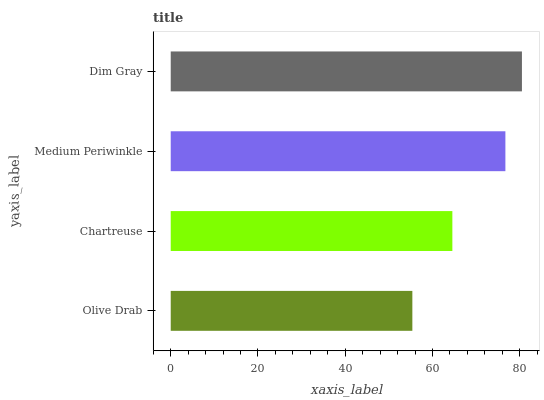Is Olive Drab the minimum?
Answer yes or no. Yes. Is Dim Gray the maximum?
Answer yes or no. Yes. Is Chartreuse the minimum?
Answer yes or no. No. Is Chartreuse the maximum?
Answer yes or no. No. Is Chartreuse greater than Olive Drab?
Answer yes or no. Yes. Is Olive Drab less than Chartreuse?
Answer yes or no. Yes. Is Olive Drab greater than Chartreuse?
Answer yes or no. No. Is Chartreuse less than Olive Drab?
Answer yes or no. No. Is Medium Periwinkle the high median?
Answer yes or no. Yes. Is Chartreuse the low median?
Answer yes or no. Yes. Is Dim Gray the high median?
Answer yes or no. No. Is Dim Gray the low median?
Answer yes or no. No. 